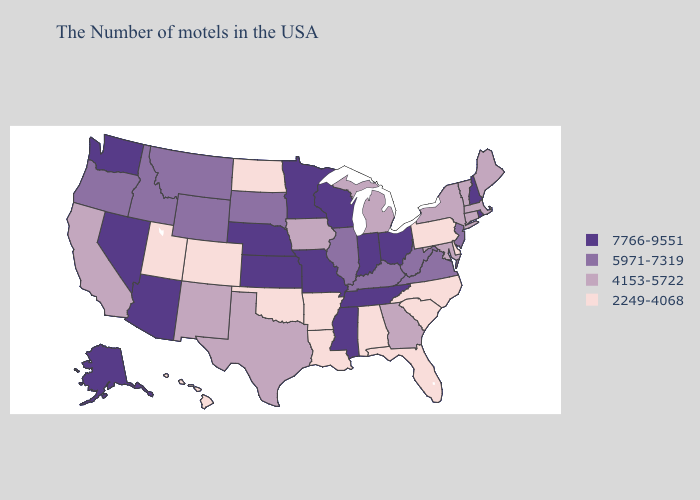Does Wyoming have the highest value in the USA?
Be succinct. No. What is the lowest value in the USA?
Concise answer only. 2249-4068. Does Iowa have a higher value than Montana?
Concise answer only. No. What is the value of New Mexico?
Answer briefly. 4153-5722. Name the states that have a value in the range 5971-7319?
Write a very short answer. New Jersey, Virginia, West Virginia, Kentucky, Illinois, South Dakota, Wyoming, Montana, Idaho, Oregon. What is the highest value in the USA?
Keep it brief. 7766-9551. What is the value of Massachusetts?
Short answer required. 4153-5722. Among the states that border Pennsylvania , does Delaware have the lowest value?
Quick response, please. Yes. Name the states that have a value in the range 5971-7319?
Be succinct. New Jersey, Virginia, West Virginia, Kentucky, Illinois, South Dakota, Wyoming, Montana, Idaho, Oregon. Name the states that have a value in the range 4153-5722?
Answer briefly. Maine, Massachusetts, Vermont, Connecticut, New York, Maryland, Georgia, Michigan, Iowa, Texas, New Mexico, California. What is the lowest value in the USA?
Short answer required. 2249-4068. Which states have the lowest value in the MidWest?
Quick response, please. North Dakota. Which states hav the highest value in the South?
Quick response, please. Tennessee, Mississippi. Does the first symbol in the legend represent the smallest category?
Give a very brief answer. No. Name the states that have a value in the range 4153-5722?
Be succinct. Maine, Massachusetts, Vermont, Connecticut, New York, Maryland, Georgia, Michigan, Iowa, Texas, New Mexico, California. 